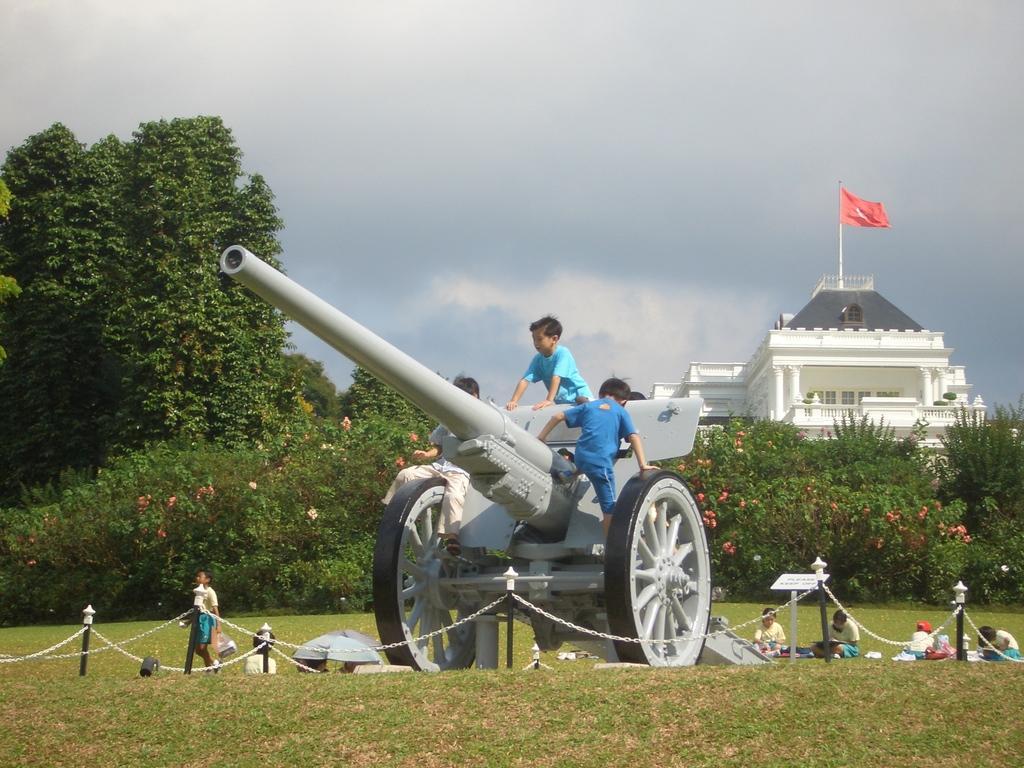Could you give a brief overview of what you see in this image? In the image we can see there are kids sitting on the war equipment and there are other people standing on the ground. The ground is covered with grass and behind there are buildings. 